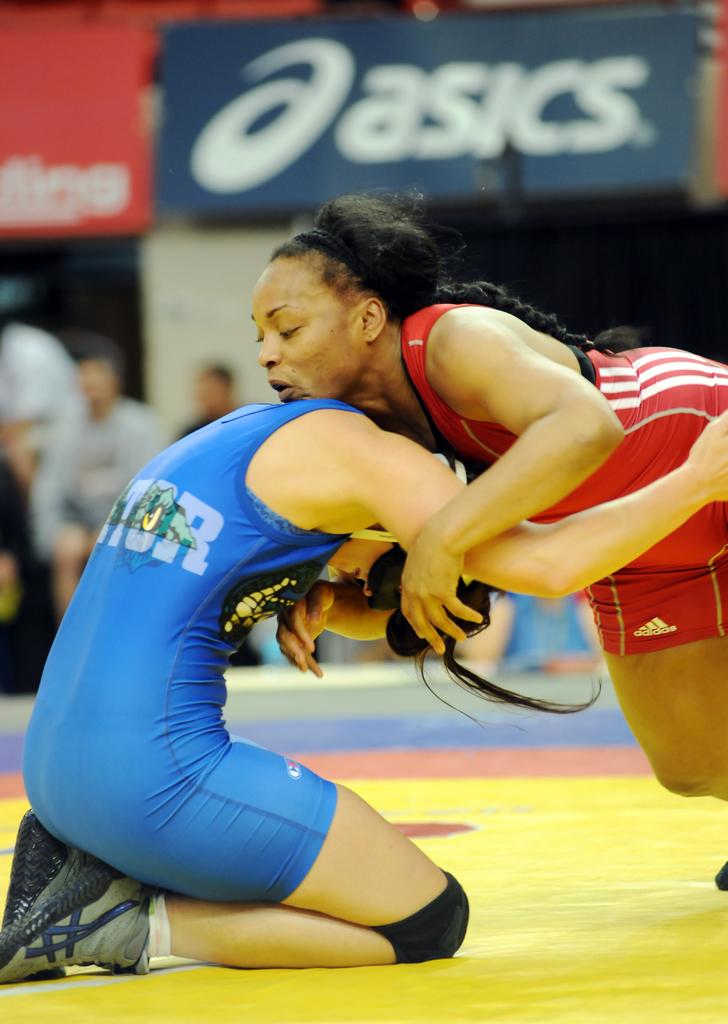What brand is advertised on a banner in the background?
Provide a short and direct response. Asics. 